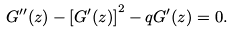<formula> <loc_0><loc_0><loc_500><loc_500>G ^ { \prime \prime } ( z ) - \left [ G ^ { \prime } ( z ) \right ] ^ { 2 } - q G ^ { \prime } ( z ) = 0 .</formula> 